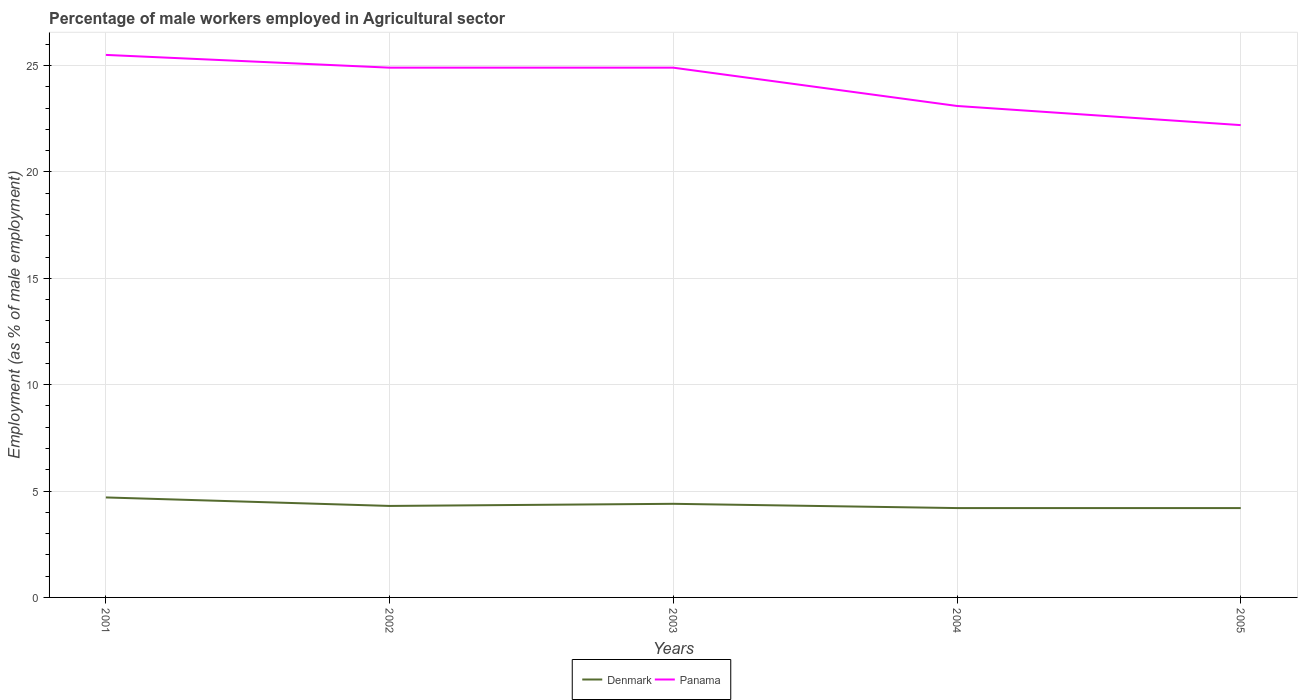How many different coloured lines are there?
Make the answer very short. 2. Does the line corresponding to Denmark intersect with the line corresponding to Panama?
Offer a terse response. No. Is the number of lines equal to the number of legend labels?
Ensure brevity in your answer.  Yes. Across all years, what is the maximum percentage of male workers employed in Agricultural sector in Panama?
Offer a very short reply. 22.2. What is the total percentage of male workers employed in Agricultural sector in Denmark in the graph?
Ensure brevity in your answer.  0.5. What is the difference between the highest and the second highest percentage of male workers employed in Agricultural sector in Denmark?
Give a very brief answer. 0.5. What is the difference between the highest and the lowest percentage of male workers employed in Agricultural sector in Denmark?
Provide a succinct answer. 2. Is the percentage of male workers employed in Agricultural sector in Denmark strictly greater than the percentage of male workers employed in Agricultural sector in Panama over the years?
Offer a terse response. Yes. Are the values on the major ticks of Y-axis written in scientific E-notation?
Provide a succinct answer. No. Does the graph contain grids?
Offer a terse response. Yes. What is the title of the graph?
Provide a short and direct response. Percentage of male workers employed in Agricultural sector. What is the label or title of the X-axis?
Offer a very short reply. Years. What is the label or title of the Y-axis?
Your response must be concise. Employment (as % of male employment). What is the Employment (as % of male employment) of Denmark in 2001?
Offer a very short reply. 4.7. What is the Employment (as % of male employment) in Panama in 2001?
Make the answer very short. 25.5. What is the Employment (as % of male employment) in Denmark in 2002?
Your response must be concise. 4.3. What is the Employment (as % of male employment) in Panama in 2002?
Make the answer very short. 24.9. What is the Employment (as % of male employment) of Denmark in 2003?
Your response must be concise. 4.4. What is the Employment (as % of male employment) of Panama in 2003?
Provide a short and direct response. 24.9. What is the Employment (as % of male employment) in Denmark in 2004?
Your response must be concise. 4.2. What is the Employment (as % of male employment) in Panama in 2004?
Your response must be concise. 23.1. What is the Employment (as % of male employment) in Denmark in 2005?
Give a very brief answer. 4.2. What is the Employment (as % of male employment) in Panama in 2005?
Offer a terse response. 22.2. Across all years, what is the maximum Employment (as % of male employment) of Denmark?
Ensure brevity in your answer.  4.7. Across all years, what is the minimum Employment (as % of male employment) of Denmark?
Your response must be concise. 4.2. Across all years, what is the minimum Employment (as % of male employment) in Panama?
Give a very brief answer. 22.2. What is the total Employment (as % of male employment) of Denmark in the graph?
Make the answer very short. 21.8. What is the total Employment (as % of male employment) in Panama in the graph?
Your answer should be very brief. 120.6. What is the difference between the Employment (as % of male employment) of Denmark in 2001 and that in 2002?
Provide a short and direct response. 0.4. What is the difference between the Employment (as % of male employment) in Denmark in 2001 and that in 2003?
Your response must be concise. 0.3. What is the difference between the Employment (as % of male employment) of Panama in 2001 and that in 2003?
Give a very brief answer. 0.6. What is the difference between the Employment (as % of male employment) in Panama in 2001 and that in 2004?
Your response must be concise. 2.4. What is the difference between the Employment (as % of male employment) of Denmark in 2001 and that in 2005?
Offer a very short reply. 0.5. What is the difference between the Employment (as % of male employment) of Denmark in 2002 and that in 2003?
Give a very brief answer. -0.1. What is the difference between the Employment (as % of male employment) in Panama in 2002 and that in 2003?
Keep it short and to the point. 0. What is the difference between the Employment (as % of male employment) in Denmark in 2002 and that in 2004?
Provide a succinct answer. 0.1. What is the difference between the Employment (as % of male employment) of Denmark in 2002 and that in 2005?
Keep it short and to the point. 0.1. What is the difference between the Employment (as % of male employment) of Denmark in 2003 and that in 2004?
Your response must be concise. 0.2. What is the difference between the Employment (as % of male employment) of Panama in 2004 and that in 2005?
Offer a terse response. 0.9. What is the difference between the Employment (as % of male employment) of Denmark in 2001 and the Employment (as % of male employment) of Panama in 2002?
Make the answer very short. -20.2. What is the difference between the Employment (as % of male employment) in Denmark in 2001 and the Employment (as % of male employment) in Panama in 2003?
Provide a short and direct response. -20.2. What is the difference between the Employment (as % of male employment) of Denmark in 2001 and the Employment (as % of male employment) of Panama in 2004?
Make the answer very short. -18.4. What is the difference between the Employment (as % of male employment) of Denmark in 2001 and the Employment (as % of male employment) of Panama in 2005?
Provide a short and direct response. -17.5. What is the difference between the Employment (as % of male employment) in Denmark in 2002 and the Employment (as % of male employment) in Panama in 2003?
Offer a terse response. -20.6. What is the difference between the Employment (as % of male employment) of Denmark in 2002 and the Employment (as % of male employment) of Panama in 2004?
Keep it short and to the point. -18.8. What is the difference between the Employment (as % of male employment) in Denmark in 2002 and the Employment (as % of male employment) in Panama in 2005?
Your answer should be very brief. -17.9. What is the difference between the Employment (as % of male employment) in Denmark in 2003 and the Employment (as % of male employment) in Panama in 2004?
Keep it short and to the point. -18.7. What is the difference between the Employment (as % of male employment) of Denmark in 2003 and the Employment (as % of male employment) of Panama in 2005?
Offer a terse response. -17.8. What is the difference between the Employment (as % of male employment) in Denmark in 2004 and the Employment (as % of male employment) in Panama in 2005?
Keep it short and to the point. -18. What is the average Employment (as % of male employment) of Denmark per year?
Your response must be concise. 4.36. What is the average Employment (as % of male employment) of Panama per year?
Give a very brief answer. 24.12. In the year 2001, what is the difference between the Employment (as % of male employment) in Denmark and Employment (as % of male employment) in Panama?
Make the answer very short. -20.8. In the year 2002, what is the difference between the Employment (as % of male employment) in Denmark and Employment (as % of male employment) in Panama?
Your answer should be compact. -20.6. In the year 2003, what is the difference between the Employment (as % of male employment) in Denmark and Employment (as % of male employment) in Panama?
Make the answer very short. -20.5. In the year 2004, what is the difference between the Employment (as % of male employment) in Denmark and Employment (as % of male employment) in Panama?
Your answer should be compact. -18.9. In the year 2005, what is the difference between the Employment (as % of male employment) of Denmark and Employment (as % of male employment) of Panama?
Give a very brief answer. -18. What is the ratio of the Employment (as % of male employment) in Denmark in 2001 to that in 2002?
Your answer should be very brief. 1.09. What is the ratio of the Employment (as % of male employment) of Panama in 2001 to that in 2002?
Your answer should be very brief. 1.02. What is the ratio of the Employment (as % of male employment) of Denmark in 2001 to that in 2003?
Ensure brevity in your answer.  1.07. What is the ratio of the Employment (as % of male employment) in Panama in 2001 to that in 2003?
Provide a succinct answer. 1.02. What is the ratio of the Employment (as % of male employment) of Denmark in 2001 to that in 2004?
Give a very brief answer. 1.12. What is the ratio of the Employment (as % of male employment) of Panama in 2001 to that in 2004?
Ensure brevity in your answer.  1.1. What is the ratio of the Employment (as % of male employment) of Denmark in 2001 to that in 2005?
Your response must be concise. 1.12. What is the ratio of the Employment (as % of male employment) in Panama in 2001 to that in 2005?
Provide a succinct answer. 1.15. What is the ratio of the Employment (as % of male employment) of Denmark in 2002 to that in 2003?
Offer a very short reply. 0.98. What is the ratio of the Employment (as % of male employment) in Panama in 2002 to that in 2003?
Offer a terse response. 1. What is the ratio of the Employment (as % of male employment) of Denmark in 2002 to that in 2004?
Offer a terse response. 1.02. What is the ratio of the Employment (as % of male employment) of Panama in 2002 to that in 2004?
Provide a succinct answer. 1.08. What is the ratio of the Employment (as % of male employment) in Denmark in 2002 to that in 2005?
Offer a very short reply. 1.02. What is the ratio of the Employment (as % of male employment) of Panama in 2002 to that in 2005?
Ensure brevity in your answer.  1.12. What is the ratio of the Employment (as % of male employment) in Denmark in 2003 to that in 2004?
Make the answer very short. 1.05. What is the ratio of the Employment (as % of male employment) of Panama in 2003 to that in 2004?
Your response must be concise. 1.08. What is the ratio of the Employment (as % of male employment) in Denmark in 2003 to that in 2005?
Provide a succinct answer. 1.05. What is the ratio of the Employment (as % of male employment) in Panama in 2003 to that in 2005?
Give a very brief answer. 1.12. What is the ratio of the Employment (as % of male employment) in Panama in 2004 to that in 2005?
Offer a terse response. 1.04. What is the difference between the highest and the second highest Employment (as % of male employment) of Denmark?
Make the answer very short. 0.3. What is the difference between the highest and the second highest Employment (as % of male employment) in Panama?
Your answer should be compact. 0.6. 